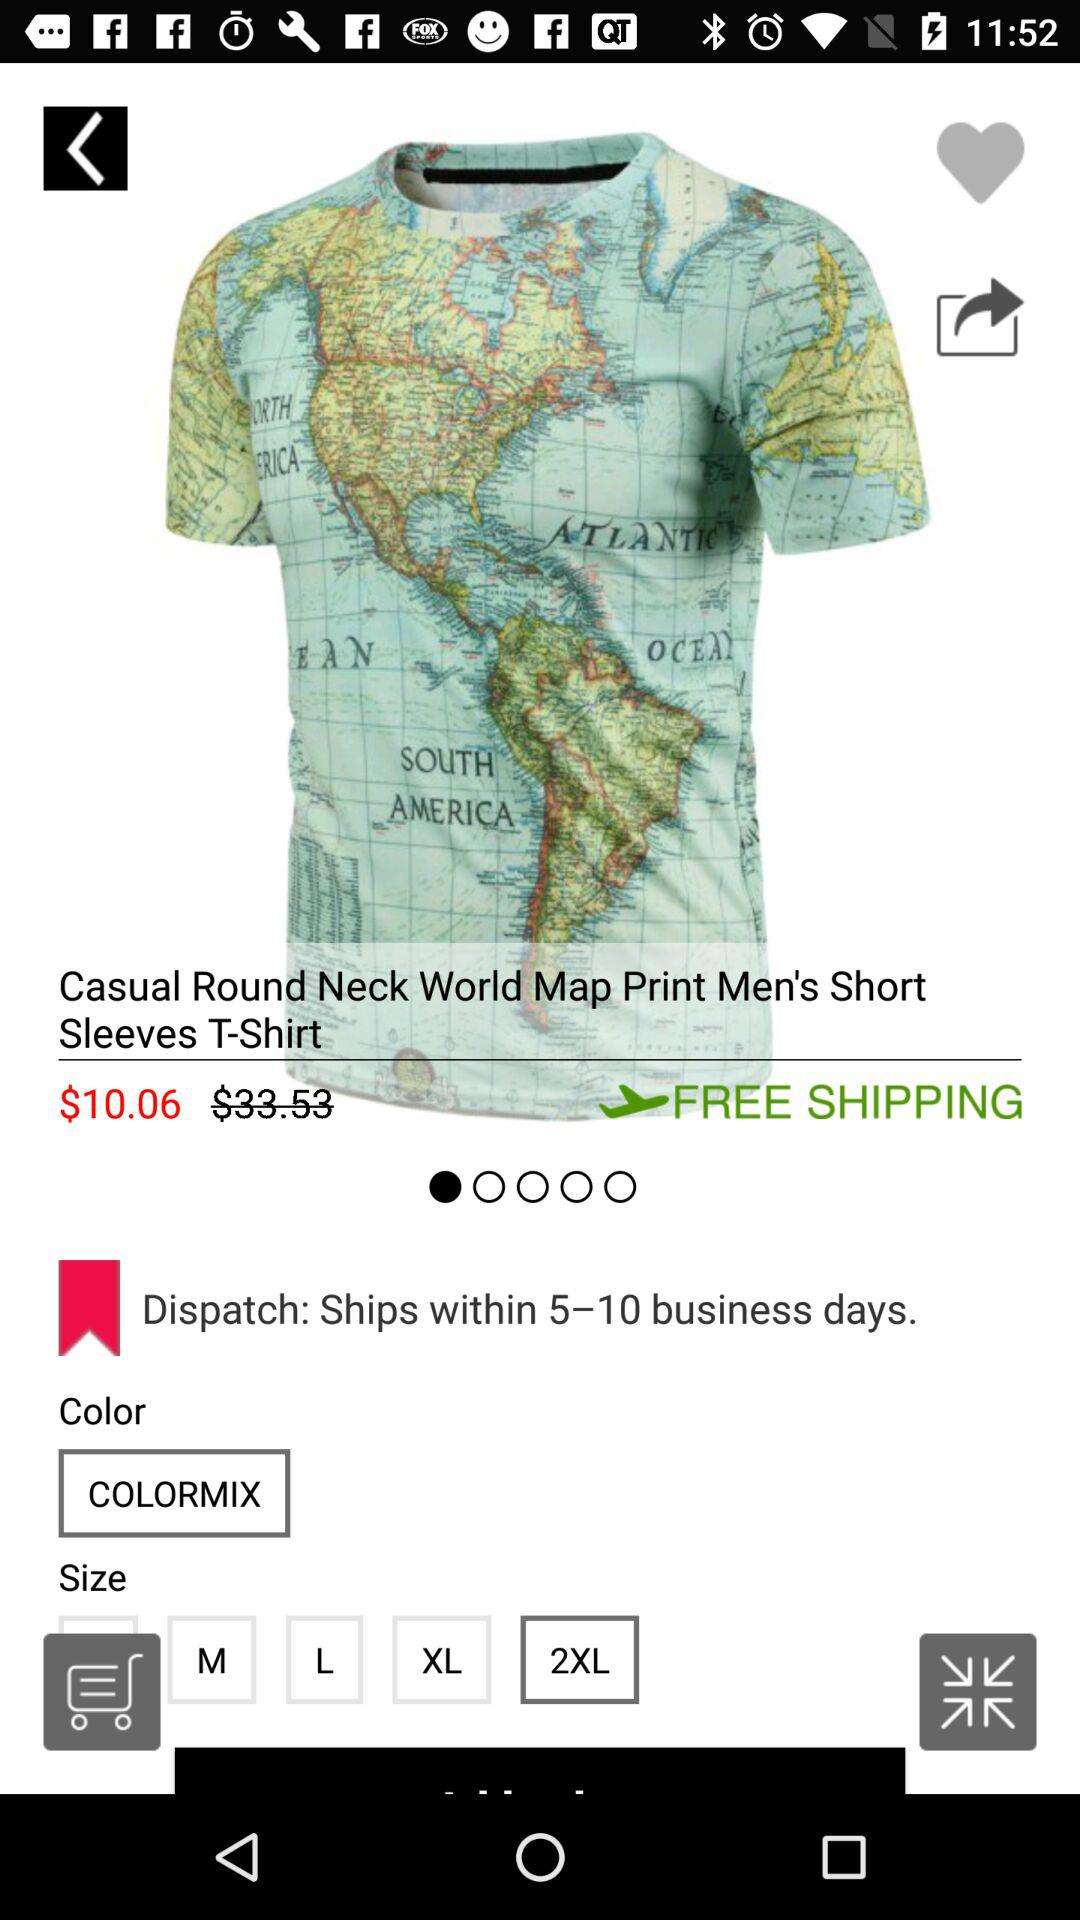In how many days, the product is dispatched? The product is dispatched within 5–10 business days. 